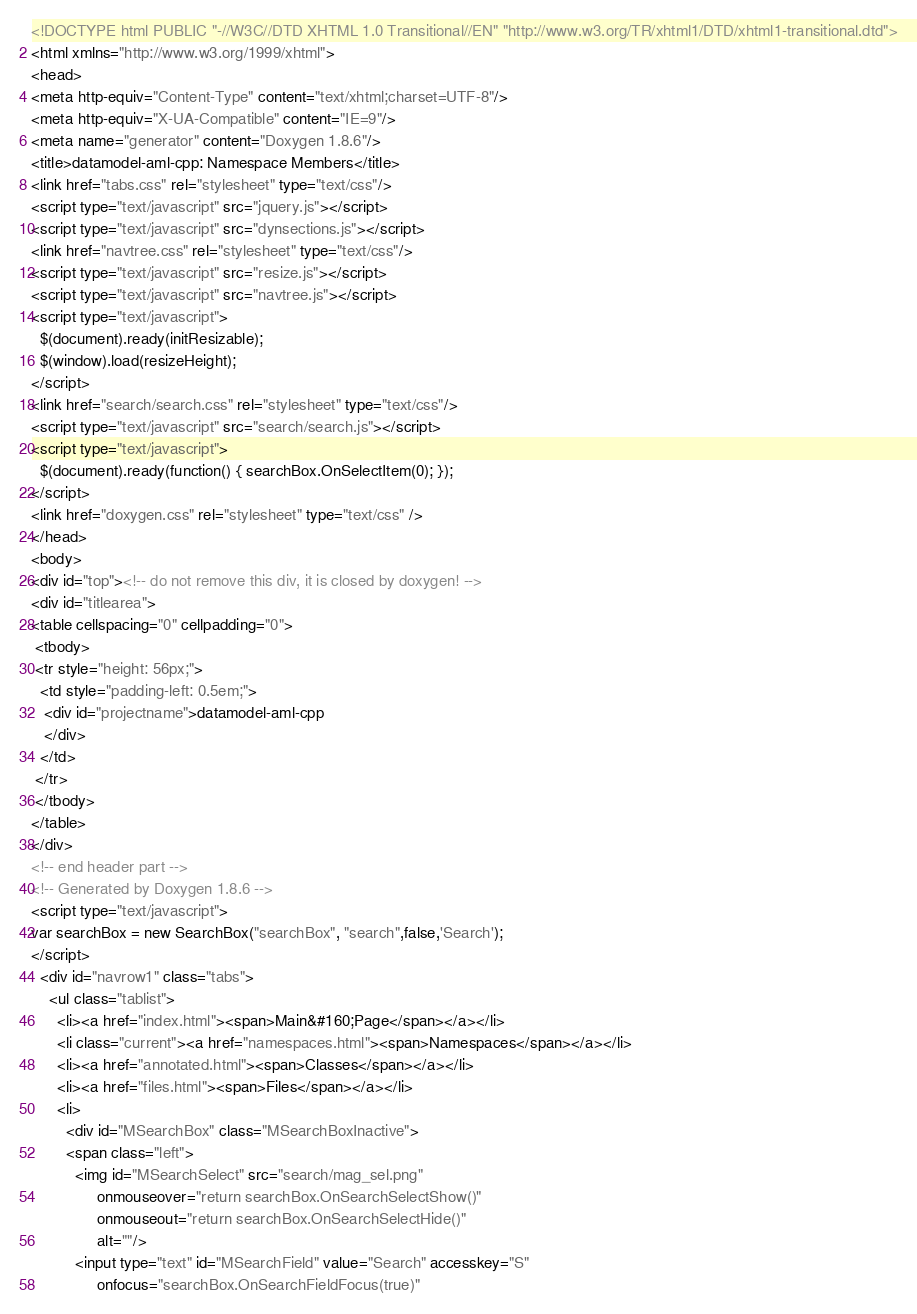Convert code to text. <code><loc_0><loc_0><loc_500><loc_500><_HTML_><!DOCTYPE html PUBLIC "-//W3C//DTD XHTML 1.0 Transitional//EN" "http://www.w3.org/TR/xhtml1/DTD/xhtml1-transitional.dtd">
<html xmlns="http://www.w3.org/1999/xhtml">
<head>
<meta http-equiv="Content-Type" content="text/xhtml;charset=UTF-8"/>
<meta http-equiv="X-UA-Compatible" content="IE=9"/>
<meta name="generator" content="Doxygen 1.8.6"/>
<title>datamodel-aml-cpp: Namespace Members</title>
<link href="tabs.css" rel="stylesheet" type="text/css"/>
<script type="text/javascript" src="jquery.js"></script>
<script type="text/javascript" src="dynsections.js"></script>
<link href="navtree.css" rel="stylesheet" type="text/css"/>
<script type="text/javascript" src="resize.js"></script>
<script type="text/javascript" src="navtree.js"></script>
<script type="text/javascript">
  $(document).ready(initResizable);
  $(window).load(resizeHeight);
</script>
<link href="search/search.css" rel="stylesheet" type="text/css"/>
<script type="text/javascript" src="search/search.js"></script>
<script type="text/javascript">
  $(document).ready(function() { searchBox.OnSelectItem(0); });
</script>
<link href="doxygen.css" rel="stylesheet" type="text/css" />
</head>
<body>
<div id="top"><!-- do not remove this div, it is closed by doxygen! -->
<div id="titlearea">
<table cellspacing="0" cellpadding="0">
 <tbody>
 <tr style="height: 56px;">
  <td style="padding-left: 0.5em;">
   <div id="projectname">datamodel-aml-cpp
   </div>
  </td>
 </tr>
 </tbody>
</table>
</div>
<!-- end header part -->
<!-- Generated by Doxygen 1.8.6 -->
<script type="text/javascript">
var searchBox = new SearchBox("searchBox", "search",false,'Search');
</script>
  <div id="navrow1" class="tabs">
    <ul class="tablist">
      <li><a href="index.html"><span>Main&#160;Page</span></a></li>
      <li class="current"><a href="namespaces.html"><span>Namespaces</span></a></li>
      <li><a href="annotated.html"><span>Classes</span></a></li>
      <li><a href="files.html"><span>Files</span></a></li>
      <li>
        <div id="MSearchBox" class="MSearchBoxInactive">
        <span class="left">
          <img id="MSearchSelect" src="search/mag_sel.png"
               onmouseover="return searchBox.OnSearchSelectShow()"
               onmouseout="return searchBox.OnSearchSelectHide()"
               alt=""/>
          <input type="text" id="MSearchField" value="Search" accesskey="S"
               onfocus="searchBox.OnSearchFieldFocus(true)" </code> 